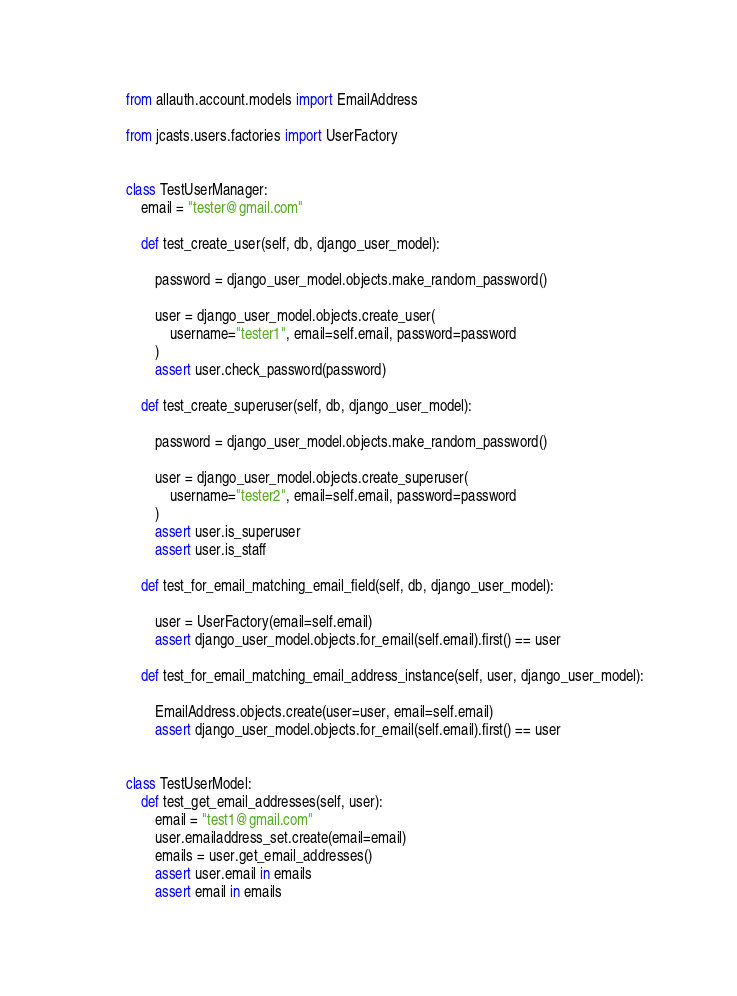<code> <loc_0><loc_0><loc_500><loc_500><_Python_>from allauth.account.models import EmailAddress

from jcasts.users.factories import UserFactory


class TestUserManager:
    email = "tester@gmail.com"

    def test_create_user(self, db, django_user_model):

        password = django_user_model.objects.make_random_password()

        user = django_user_model.objects.create_user(
            username="tester1", email=self.email, password=password
        )
        assert user.check_password(password)

    def test_create_superuser(self, db, django_user_model):

        password = django_user_model.objects.make_random_password()

        user = django_user_model.objects.create_superuser(
            username="tester2", email=self.email, password=password
        )
        assert user.is_superuser
        assert user.is_staff

    def test_for_email_matching_email_field(self, db, django_user_model):

        user = UserFactory(email=self.email)
        assert django_user_model.objects.for_email(self.email).first() == user

    def test_for_email_matching_email_address_instance(self, user, django_user_model):

        EmailAddress.objects.create(user=user, email=self.email)
        assert django_user_model.objects.for_email(self.email).first() == user


class TestUserModel:
    def test_get_email_addresses(self, user):
        email = "test1@gmail.com"
        user.emailaddress_set.create(email=email)
        emails = user.get_email_addresses()
        assert user.email in emails
        assert email in emails
</code> 